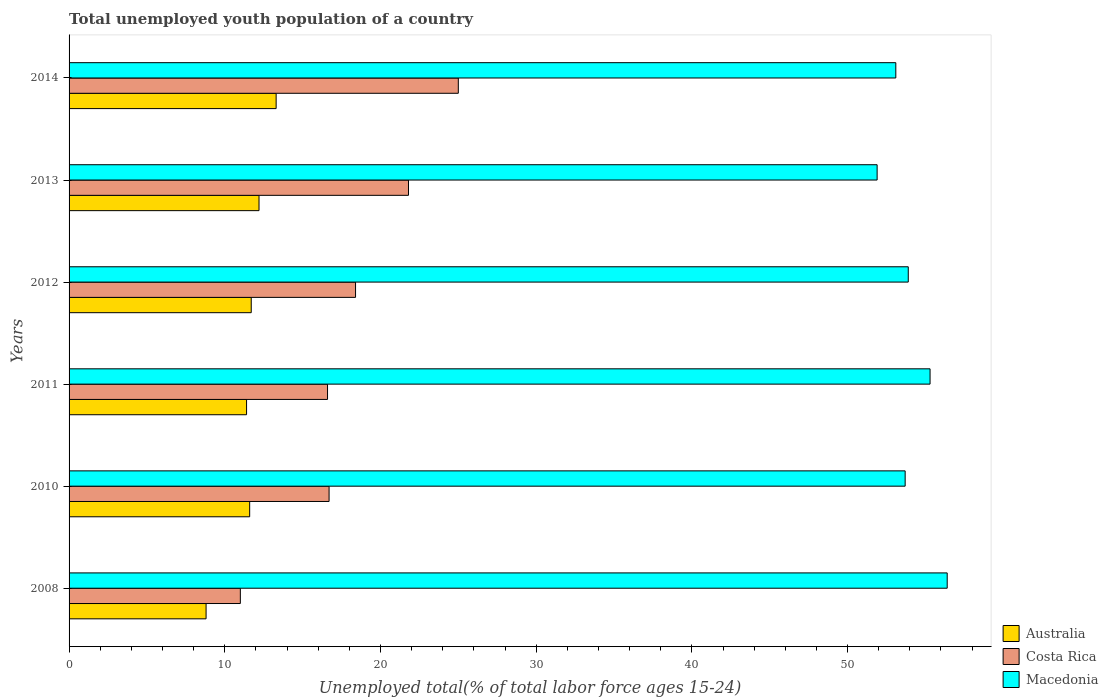How many groups of bars are there?
Provide a succinct answer. 6. Are the number of bars per tick equal to the number of legend labels?
Keep it short and to the point. Yes. How many bars are there on the 3rd tick from the top?
Give a very brief answer. 3. What is the percentage of total unemployed youth population of a country in Costa Rica in 2013?
Offer a very short reply. 21.8. Across all years, what is the minimum percentage of total unemployed youth population of a country in Australia?
Your answer should be compact. 8.8. In which year was the percentage of total unemployed youth population of a country in Macedonia maximum?
Give a very brief answer. 2008. In which year was the percentage of total unemployed youth population of a country in Macedonia minimum?
Ensure brevity in your answer.  2013. What is the total percentage of total unemployed youth population of a country in Costa Rica in the graph?
Provide a succinct answer. 109.5. What is the difference between the percentage of total unemployed youth population of a country in Australia in 2011 and the percentage of total unemployed youth population of a country in Costa Rica in 2014?
Your response must be concise. -13.6. What is the average percentage of total unemployed youth population of a country in Macedonia per year?
Keep it short and to the point. 54.05. In the year 2014, what is the difference between the percentage of total unemployed youth population of a country in Costa Rica and percentage of total unemployed youth population of a country in Macedonia?
Keep it short and to the point. -28.1. What is the ratio of the percentage of total unemployed youth population of a country in Australia in 2012 to that in 2013?
Provide a succinct answer. 0.96. What is the difference between the highest and the second highest percentage of total unemployed youth population of a country in Costa Rica?
Your answer should be compact. 3.2. What is the difference between the highest and the lowest percentage of total unemployed youth population of a country in Australia?
Make the answer very short. 4.5. In how many years, is the percentage of total unemployed youth population of a country in Macedonia greater than the average percentage of total unemployed youth population of a country in Macedonia taken over all years?
Make the answer very short. 2. What does the 1st bar from the top in 2013 represents?
Make the answer very short. Macedonia. What does the 3rd bar from the bottom in 2010 represents?
Your answer should be very brief. Macedonia. How many years are there in the graph?
Keep it short and to the point. 6. What is the title of the graph?
Your answer should be compact. Total unemployed youth population of a country. Does "Least developed countries" appear as one of the legend labels in the graph?
Make the answer very short. No. What is the label or title of the X-axis?
Offer a terse response. Unemployed total(% of total labor force ages 15-24). What is the Unemployed total(% of total labor force ages 15-24) of Australia in 2008?
Offer a very short reply. 8.8. What is the Unemployed total(% of total labor force ages 15-24) of Macedonia in 2008?
Make the answer very short. 56.4. What is the Unemployed total(% of total labor force ages 15-24) in Australia in 2010?
Offer a terse response. 11.6. What is the Unemployed total(% of total labor force ages 15-24) in Costa Rica in 2010?
Give a very brief answer. 16.7. What is the Unemployed total(% of total labor force ages 15-24) of Macedonia in 2010?
Give a very brief answer. 53.7. What is the Unemployed total(% of total labor force ages 15-24) in Australia in 2011?
Provide a short and direct response. 11.4. What is the Unemployed total(% of total labor force ages 15-24) in Costa Rica in 2011?
Provide a short and direct response. 16.6. What is the Unemployed total(% of total labor force ages 15-24) of Macedonia in 2011?
Your response must be concise. 55.3. What is the Unemployed total(% of total labor force ages 15-24) of Australia in 2012?
Your answer should be very brief. 11.7. What is the Unemployed total(% of total labor force ages 15-24) of Costa Rica in 2012?
Ensure brevity in your answer.  18.4. What is the Unemployed total(% of total labor force ages 15-24) in Macedonia in 2012?
Ensure brevity in your answer.  53.9. What is the Unemployed total(% of total labor force ages 15-24) in Australia in 2013?
Give a very brief answer. 12.2. What is the Unemployed total(% of total labor force ages 15-24) of Costa Rica in 2013?
Offer a terse response. 21.8. What is the Unemployed total(% of total labor force ages 15-24) in Macedonia in 2013?
Offer a terse response. 51.9. What is the Unemployed total(% of total labor force ages 15-24) in Australia in 2014?
Ensure brevity in your answer.  13.3. What is the Unemployed total(% of total labor force ages 15-24) in Macedonia in 2014?
Give a very brief answer. 53.1. Across all years, what is the maximum Unemployed total(% of total labor force ages 15-24) of Australia?
Your answer should be very brief. 13.3. Across all years, what is the maximum Unemployed total(% of total labor force ages 15-24) of Costa Rica?
Keep it short and to the point. 25. Across all years, what is the maximum Unemployed total(% of total labor force ages 15-24) of Macedonia?
Your answer should be very brief. 56.4. Across all years, what is the minimum Unemployed total(% of total labor force ages 15-24) in Australia?
Offer a terse response. 8.8. Across all years, what is the minimum Unemployed total(% of total labor force ages 15-24) in Costa Rica?
Ensure brevity in your answer.  11. Across all years, what is the minimum Unemployed total(% of total labor force ages 15-24) of Macedonia?
Offer a terse response. 51.9. What is the total Unemployed total(% of total labor force ages 15-24) in Costa Rica in the graph?
Provide a short and direct response. 109.5. What is the total Unemployed total(% of total labor force ages 15-24) of Macedonia in the graph?
Ensure brevity in your answer.  324.3. What is the difference between the Unemployed total(% of total labor force ages 15-24) in Australia in 2008 and that in 2010?
Offer a terse response. -2.8. What is the difference between the Unemployed total(% of total labor force ages 15-24) of Australia in 2008 and that in 2011?
Your response must be concise. -2.6. What is the difference between the Unemployed total(% of total labor force ages 15-24) of Costa Rica in 2008 and that in 2011?
Provide a succinct answer. -5.6. What is the difference between the Unemployed total(% of total labor force ages 15-24) of Macedonia in 2008 and that in 2012?
Give a very brief answer. 2.5. What is the difference between the Unemployed total(% of total labor force ages 15-24) in Costa Rica in 2008 and that in 2013?
Ensure brevity in your answer.  -10.8. What is the difference between the Unemployed total(% of total labor force ages 15-24) in Macedonia in 2008 and that in 2014?
Ensure brevity in your answer.  3.3. What is the difference between the Unemployed total(% of total labor force ages 15-24) of Australia in 2010 and that in 2011?
Your answer should be very brief. 0.2. What is the difference between the Unemployed total(% of total labor force ages 15-24) of Costa Rica in 2010 and that in 2011?
Your response must be concise. 0.1. What is the difference between the Unemployed total(% of total labor force ages 15-24) in Macedonia in 2010 and that in 2012?
Your response must be concise. -0.2. What is the difference between the Unemployed total(% of total labor force ages 15-24) in Australia in 2010 and that in 2013?
Offer a very short reply. -0.6. What is the difference between the Unemployed total(% of total labor force ages 15-24) in Macedonia in 2010 and that in 2014?
Offer a very short reply. 0.6. What is the difference between the Unemployed total(% of total labor force ages 15-24) in Australia in 2011 and that in 2014?
Make the answer very short. -1.9. What is the difference between the Unemployed total(% of total labor force ages 15-24) of Macedonia in 2011 and that in 2014?
Provide a succinct answer. 2.2. What is the difference between the Unemployed total(% of total labor force ages 15-24) of Costa Rica in 2012 and that in 2013?
Make the answer very short. -3.4. What is the difference between the Unemployed total(% of total labor force ages 15-24) in Macedonia in 2012 and that in 2013?
Keep it short and to the point. 2. What is the difference between the Unemployed total(% of total labor force ages 15-24) in Australia in 2012 and that in 2014?
Your response must be concise. -1.6. What is the difference between the Unemployed total(% of total labor force ages 15-24) of Costa Rica in 2012 and that in 2014?
Offer a very short reply. -6.6. What is the difference between the Unemployed total(% of total labor force ages 15-24) in Australia in 2013 and that in 2014?
Provide a succinct answer. -1.1. What is the difference between the Unemployed total(% of total labor force ages 15-24) of Costa Rica in 2013 and that in 2014?
Offer a terse response. -3.2. What is the difference between the Unemployed total(% of total labor force ages 15-24) of Macedonia in 2013 and that in 2014?
Your answer should be compact. -1.2. What is the difference between the Unemployed total(% of total labor force ages 15-24) in Australia in 2008 and the Unemployed total(% of total labor force ages 15-24) in Macedonia in 2010?
Offer a very short reply. -44.9. What is the difference between the Unemployed total(% of total labor force ages 15-24) of Costa Rica in 2008 and the Unemployed total(% of total labor force ages 15-24) of Macedonia in 2010?
Your answer should be very brief. -42.7. What is the difference between the Unemployed total(% of total labor force ages 15-24) in Australia in 2008 and the Unemployed total(% of total labor force ages 15-24) in Macedonia in 2011?
Your answer should be compact. -46.5. What is the difference between the Unemployed total(% of total labor force ages 15-24) in Costa Rica in 2008 and the Unemployed total(% of total labor force ages 15-24) in Macedonia in 2011?
Your answer should be very brief. -44.3. What is the difference between the Unemployed total(% of total labor force ages 15-24) of Australia in 2008 and the Unemployed total(% of total labor force ages 15-24) of Macedonia in 2012?
Your answer should be compact. -45.1. What is the difference between the Unemployed total(% of total labor force ages 15-24) in Costa Rica in 2008 and the Unemployed total(% of total labor force ages 15-24) in Macedonia in 2012?
Make the answer very short. -42.9. What is the difference between the Unemployed total(% of total labor force ages 15-24) in Australia in 2008 and the Unemployed total(% of total labor force ages 15-24) in Macedonia in 2013?
Your answer should be compact. -43.1. What is the difference between the Unemployed total(% of total labor force ages 15-24) of Costa Rica in 2008 and the Unemployed total(% of total labor force ages 15-24) of Macedonia in 2013?
Your answer should be compact. -40.9. What is the difference between the Unemployed total(% of total labor force ages 15-24) of Australia in 2008 and the Unemployed total(% of total labor force ages 15-24) of Costa Rica in 2014?
Your response must be concise. -16.2. What is the difference between the Unemployed total(% of total labor force ages 15-24) of Australia in 2008 and the Unemployed total(% of total labor force ages 15-24) of Macedonia in 2014?
Keep it short and to the point. -44.3. What is the difference between the Unemployed total(% of total labor force ages 15-24) of Costa Rica in 2008 and the Unemployed total(% of total labor force ages 15-24) of Macedonia in 2014?
Ensure brevity in your answer.  -42.1. What is the difference between the Unemployed total(% of total labor force ages 15-24) in Australia in 2010 and the Unemployed total(% of total labor force ages 15-24) in Costa Rica in 2011?
Ensure brevity in your answer.  -5. What is the difference between the Unemployed total(% of total labor force ages 15-24) in Australia in 2010 and the Unemployed total(% of total labor force ages 15-24) in Macedonia in 2011?
Provide a succinct answer. -43.7. What is the difference between the Unemployed total(% of total labor force ages 15-24) of Costa Rica in 2010 and the Unemployed total(% of total labor force ages 15-24) of Macedonia in 2011?
Ensure brevity in your answer.  -38.6. What is the difference between the Unemployed total(% of total labor force ages 15-24) of Australia in 2010 and the Unemployed total(% of total labor force ages 15-24) of Macedonia in 2012?
Provide a short and direct response. -42.3. What is the difference between the Unemployed total(% of total labor force ages 15-24) of Costa Rica in 2010 and the Unemployed total(% of total labor force ages 15-24) of Macedonia in 2012?
Your answer should be very brief. -37.2. What is the difference between the Unemployed total(% of total labor force ages 15-24) of Australia in 2010 and the Unemployed total(% of total labor force ages 15-24) of Costa Rica in 2013?
Provide a succinct answer. -10.2. What is the difference between the Unemployed total(% of total labor force ages 15-24) in Australia in 2010 and the Unemployed total(% of total labor force ages 15-24) in Macedonia in 2013?
Give a very brief answer. -40.3. What is the difference between the Unemployed total(% of total labor force ages 15-24) of Costa Rica in 2010 and the Unemployed total(% of total labor force ages 15-24) of Macedonia in 2013?
Provide a succinct answer. -35.2. What is the difference between the Unemployed total(% of total labor force ages 15-24) of Australia in 2010 and the Unemployed total(% of total labor force ages 15-24) of Costa Rica in 2014?
Your answer should be very brief. -13.4. What is the difference between the Unemployed total(% of total labor force ages 15-24) in Australia in 2010 and the Unemployed total(% of total labor force ages 15-24) in Macedonia in 2014?
Make the answer very short. -41.5. What is the difference between the Unemployed total(% of total labor force ages 15-24) in Costa Rica in 2010 and the Unemployed total(% of total labor force ages 15-24) in Macedonia in 2014?
Give a very brief answer. -36.4. What is the difference between the Unemployed total(% of total labor force ages 15-24) of Australia in 2011 and the Unemployed total(% of total labor force ages 15-24) of Costa Rica in 2012?
Keep it short and to the point. -7. What is the difference between the Unemployed total(% of total labor force ages 15-24) of Australia in 2011 and the Unemployed total(% of total labor force ages 15-24) of Macedonia in 2012?
Your response must be concise. -42.5. What is the difference between the Unemployed total(% of total labor force ages 15-24) in Costa Rica in 2011 and the Unemployed total(% of total labor force ages 15-24) in Macedonia in 2012?
Offer a very short reply. -37.3. What is the difference between the Unemployed total(% of total labor force ages 15-24) in Australia in 2011 and the Unemployed total(% of total labor force ages 15-24) in Macedonia in 2013?
Ensure brevity in your answer.  -40.5. What is the difference between the Unemployed total(% of total labor force ages 15-24) of Costa Rica in 2011 and the Unemployed total(% of total labor force ages 15-24) of Macedonia in 2013?
Provide a succinct answer. -35.3. What is the difference between the Unemployed total(% of total labor force ages 15-24) in Australia in 2011 and the Unemployed total(% of total labor force ages 15-24) in Macedonia in 2014?
Give a very brief answer. -41.7. What is the difference between the Unemployed total(% of total labor force ages 15-24) of Costa Rica in 2011 and the Unemployed total(% of total labor force ages 15-24) of Macedonia in 2014?
Offer a terse response. -36.5. What is the difference between the Unemployed total(% of total labor force ages 15-24) of Australia in 2012 and the Unemployed total(% of total labor force ages 15-24) of Macedonia in 2013?
Offer a terse response. -40.2. What is the difference between the Unemployed total(% of total labor force ages 15-24) in Costa Rica in 2012 and the Unemployed total(% of total labor force ages 15-24) in Macedonia in 2013?
Give a very brief answer. -33.5. What is the difference between the Unemployed total(% of total labor force ages 15-24) of Australia in 2012 and the Unemployed total(% of total labor force ages 15-24) of Macedonia in 2014?
Your response must be concise. -41.4. What is the difference between the Unemployed total(% of total labor force ages 15-24) in Costa Rica in 2012 and the Unemployed total(% of total labor force ages 15-24) in Macedonia in 2014?
Ensure brevity in your answer.  -34.7. What is the difference between the Unemployed total(% of total labor force ages 15-24) in Australia in 2013 and the Unemployed total(% of total labor force ages 15-24) in Costa Rica in 2014?
Keep it short and to the point. -12.8. What is the difference between the Unemployed total(% of total labor force ages 15-24) in Australia in 2013 and the Unemployed total(% of total labor force ages 15-24) in Macedonia in 2014?
Offer a very short reply. -40.9. What is the difference between the Unemployed total(% of total labor force ages 15-24) in Costa Rica in 2013 and the Unemployed total(% of total labor force ages 15-24) in Macedonia in 2014?
Offer a terse response. -31.3. What is the average Unemployed total(% of total labor force ages 15-24) in Australia per year?
Your answer should be very brief. 11.5. What is the average Unemployed total(% of total labor force ages 15-24) in Costa Rica per year?
Ensure brevity in your answer.  18.25. What is the average Unemployed total(% of total labor force ages 15-24) in Macedonia per year?
Provide a short and direct response. 54.05. In the year 2008, what is the difference between the Unemployed total(% of total labor force ages 15-24) in Australia and Unemployed total(% of total labor force ages 15-24) in Costa Rica?
Make the answer very short. -2.2. In the year 2008, what is the difference between the Unemployed total(% of total labor force ages 15-24) of Australia and Unemployed total(% of total labor force ages 15-24) of Macedonia?
Offer a very short reply. -47.6. In the year 2008, what is the difference between the Unemployed total(% of total labor force ages 15-24) of Costa Rica and Unemployed total(% of total labor force ages 15-24) of Macedonia?
Provide a succinct answer. -45.4. In the year 2010, what is the difference between the Unemployed total(% of total labor force ages 15-24) in Australia and Unemployed total(% of total labor force ages 15-24) in Macedonia?
Your response must be concise. -42.1. In the year 2010, what is the difference between the Unemployed total(% of total labor force ages 15-24) of Costa Rica and Unemployed total(% of total labor force ages 15-24) of Macedonia?
Your answer should be very brief. -37. In the year 2011, what is the difference between the Unemployed total(% of total labor force ages 15-24) in Australia and Unemployed total(% of total labor force ages 15-24) in Macedonia?
Provide a short and direct response. -43.9. In the year 2011, what is the difference between the Unemployed total(% of total labor force ages 15-24) of Costa Rica and Unemployed total(% of total labor force ages 15-24) of Macedonia?
Your answer should be very brief. -38.7. In the year 2012, what is the difference between the Unemployed total(% of total labor force ages 15-24) in Australia and Unemployed total(% of total labor force ages 15-24) in Macedonia?
Your response must be concise. -42.2. In the year 2012, what is the difference between the Unemployed total(% of total labor force ages 15-24) in Costa Rica and Unemployed total(% of total labor force ages 15-24) in Macedonia?
Your answer should be compact. -35.5. In the year 2013, what is the difference between the Unemployed total(% of total labor force ages 15-24) of Australia and Unemployed total(% of total labor force ages 15-24) of Macedonia?
Your response must be concise. -39.7. In the year 2013, what is the difference between the Unemployed total(% of total labor force ages 15-24) in Costa Rica and Unemployed total(% of total labor force ages 15-24) in Macedonia?
Provide a succinct answer. -30.1. In the year 2014, what is the difference between the Unemployed total(% of total labor force ages 15-24) in Australia and Unemployed total(% of total labor force ages 15-24) in Macedonia?
Make the answer very short. -39.8. In the year 2014, what is the difference between the Unemployed total(% of total labor force ages 15-24) of Costa Rica and Unemployed total(% of total labor force ages 15-24) of Macedonia?
Provide a succinct answer. -28.1. What is the ratio of the Unemployed total(% of total labor force ages 15-24) of Australia in 2008 to that in 2010?
Provide a succinct answer. 0.76. What is the ratio of the Unemployed total(% of total labor force ages 15-24) of Costa Rica in 2008 to that in 2010?
Keep it short and to the point. 0.66. What is the ratio of the Unemployed total(% of total labor force ages 15-24) of Macedonia in 2008 to that in 2010?
Your answer should be compact. 1.05. What is the ratio of the Unemployed total(% of total labor force ages 15-24) of Australia in 2008 to that in 2011?
Offer a terse response. 0.77. What is the ratio of the Unemployed total(% of total labor force ages 15-24) of Costa Rica in 2008 to that in 2011?
Provide a short and direct response. 0.66. What is the ratio of the Unemployed total(% of total labor force ages 15-24) in Macedonia in 2008 to that in 2011?
Your response must be concise. 1.02. What is the ratio of the Unemployed total(% of total labor force ages 15-24) of Australia in 2008 to that in 2012?
Provide a short and direct response. 0.75. What is the ratio of the Unemployed total(% of total labor force ages 15-24) of Costa Rica in 2008 to that in 2012?
Offer a very short reply. 0.6. What is the ratio of the Unemployed total(% of total labor force ages 15-24) of Macedonia in 2008 to that in 2012?
Provide a succinct answer. 1.05. What is the ratio of the Unemployed total(% of total labor force ages 15-24) of Australia in 2008 to that in 2013?
Provide a succinct answer. 0.72. What is the ratio of the Unemployed total(% of total labor force ages 15-24) in Costa Rica in 2008 to that in 2013?
Your answer should be compact. 0.5. What is the ratio of the Unemployed total(% of total labor force ages 15-24) in Macedonia in 2008 to that in 2013?
Your answer should be compact. 1.09. What is the ratio of the Unemployed total(% of total labor force ages 15-24) in Australia in 2008 to that in 2014?
Provide a short and direct response. 0.66. What is the ratio of the Unemployed total(% of total labor force ages 15-24) of Costa Rica in 2008 to that in 2014?
Provide a short and direct response. 0.44. What is the ratio of the Unemployed total(% of total labor force ages 15-24) in Macedonia in 2008 to that in 2014?
Make the answer very short. 1.06. What is the ratio of the Unemployed total(% of total labor force ages 15-24) of Australia in 2010 to that in 2011?
Offer a terse response. 1.02. What is the ratio of the Unemployed total(% of total labor force ages 15-24) of Costa Rica in 2010 to that in 2011?
Your response must be concise. 1.01. What is the ratio of the Unemployed total(% of total labor force ages 15-24) of Macedonia in 2010 to that in 2011?
Make the answer very short. 0.97. What is the ratio of the Unemployed total(% of total labor force ages 15-24) of Costa Rica in 2010 to that in 2012?
Your answer should be very brief. 0.91. What is the ratio of the Unemployed total(% of total labor force ages 15-24) in Australia in 2010 to that in 2013?
Provide a succinct answer. 0.95. What is the ratio of the Unemployed total(% of total labor force ages 15-24) of Costa Rica in 2010 to that in 2013?
Provide a short and direct response. 0.77. What is the ratio of the Unemployed total(% of total labor force ages 15-24) in Macedonia in 2010 to that in 2013?
Ensure brevity in your answer.  1.03. What is the ratio of the Unemployed total(% of total labor force ages 15-24) in Australia in 2010 to that in 2014?
Your response must be concise. 0.87. What is the ratio of the Unemployed total(% of total labor force ages 15-24) in Costa Rica in 2010 to that in 2014?
Offer a very short reply. 0.67. What is the ratio of the Unemployed total(% of total labor force ages 15-24) of Macedonia in 2010 to that in 2014?
Offer a terse response. 1.01. What is the ratio of the Unemployed total(% of total labor force ages 15-24) of Australia in 2011 to that in 2012?
Make the answer very short. 0.97. What is the ratio of the Unemployed total(% of total labor force ages 15-24) in Costa Rica in 2011 to that in 2012?
Make the answer very short. 0.9. What is the ratio of the Unemployed total(% of total labor force ages 15-24) of Australia in 2011 to that in 2013?
Give a very brief answer. 0.93. What is the ratio of the Unemployed total(% of total labor force ages 15-24) of Costa Rica in 2011 to that in 2013?
Make the answer very short. 0.76. What is the ratio of the Unemployed total(% of total labor force ages 15-24) in Macedonia in 2011 to that in 2013?
Your answer should be compact. 1.07. What is the ratio of the Unemployed total(% of total labor force ages 15-24) of Australia in 2011 to that in 2014?
Give a very brief answer. 0.86. What is the ratio of the Unemployed total(% of total labor force ages 15-24) in Costa Rica in 2011 to that in 2014?
Offer a terse response. 0.66. What is the ratio of the Unemployed total(% of total labor force ages 15-24) in Macedonia in 2011 to that in 2014?
Your answer should be compact. 1.04. What is the ratio of the Unemployed total(% of total labor force ages 15-24) of Australia in 2012 to that in 2013?
Your answer should be compact. 0.96. What is the ratio of the Unemployed total(% of total labor force ages 15-24) in Costa Rica in 2012 to that in 2013?
Provide a succinct answer. 0.84. What is the ratio of the Unemployed total(% of total labor force ages 15-24) in Australia in 2012 to that in 2014?
Your answer should be compact. 0.88. What is the ratio of the Unemployed total(% of total labor force ages 15-24) of Costa Rica in 2012 to that in 2014?
Offer a very short reply. 0.74. What is the ratio of the Unemployed total(% of total labor force ages 15-24) of Macedonia in 2012 to that in 2014?
Your answer should be compact. 1.02. What is the ratio of the Unemployed total(% of total labor force ages 15-24) in Australia in 2013 to that in 2014?
Keep it short and to the point. 0.92. What is the ratio of the Unemployed total(% of total labor force ages 15-24) of Costa Rica in 2013 to that in 2014?
Offer a terse response. 0.87. What is the ratio of the Unemployed total(% of total labor force ages 15-24) in Macedonia in 2013 to that in 2014?
Make the answer very short. 0.98. What is the difference between the highest and the second highest Unemployed total(% of total labor force ages 15-24) in Australia?
Your answer should be very brief. 1.1. What is the difference between the highest and the second highest Unemployed total(% of total labor force ages 15-24) in Costa Rica?
Your answer should be very brief. 3.2. What is the difference between the highest and the lowest Unemployed total(% of total labor force ages 15-24) in Australia?
Keep it short and to the point. 4.5. What is the difference between the highest and the lowest Unemployed total(% of total labor force ages 15-24) of Costa Rica?
Keep it short and to the point. 14. 